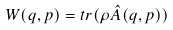<formula> <loc_0><loc_0><loc_500><loc_500>W ( q , p ) = t r ( \rho \hat { A } ( q , p ) )</formula> 